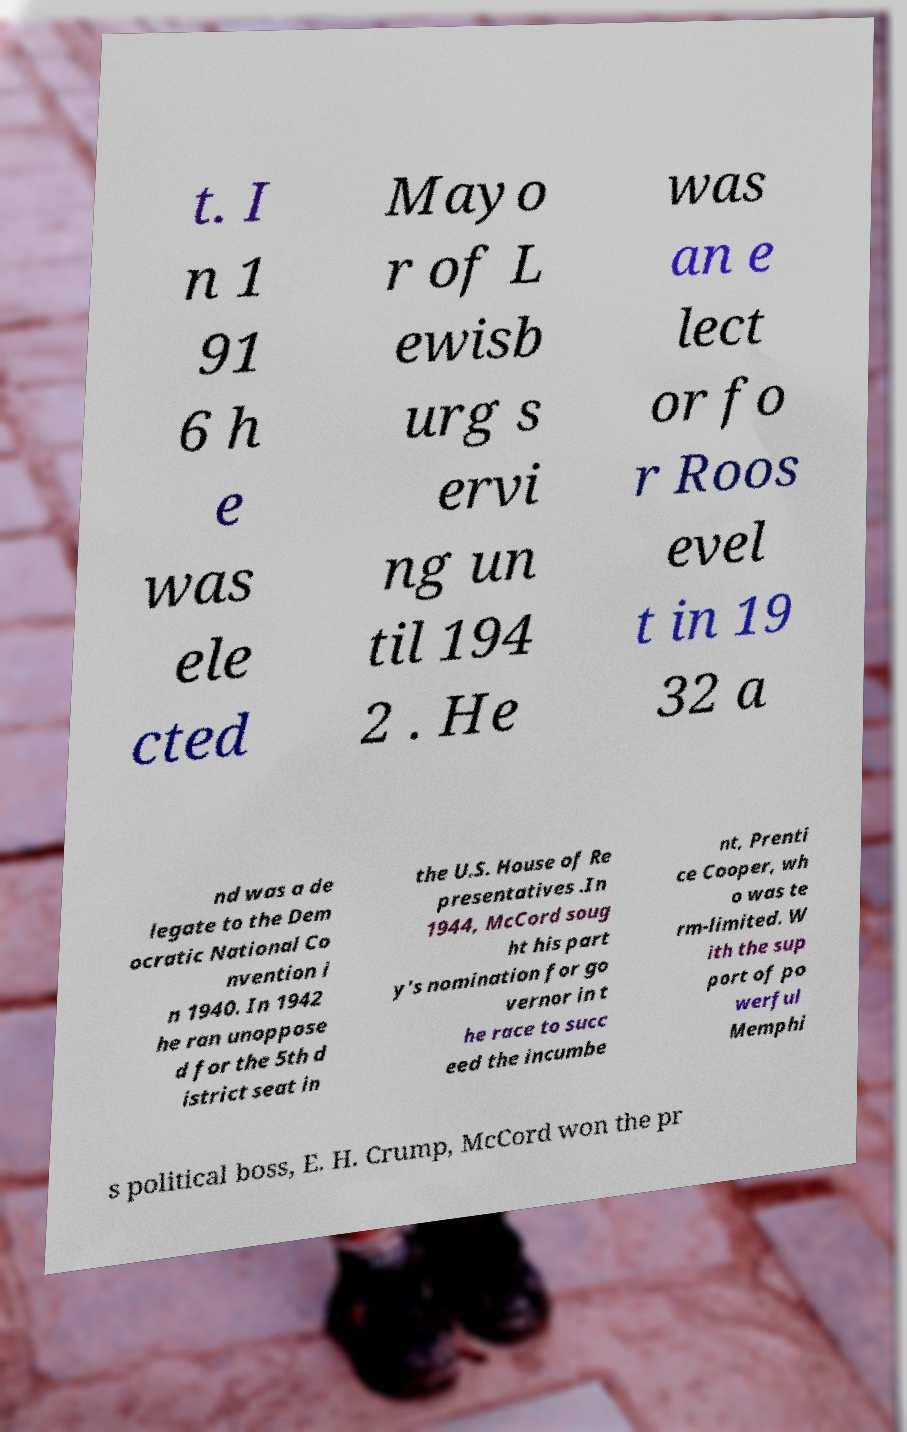Please identify and transcribe the text found in this image. t. I n 1 91 6 h e was ele cted Mayo r of L ewisb urg s ervi ng un til 194 2 . He was an e lect or fo r Roos evel t in 19 32 a nd was a de legate to the Dem ocratic National Co nvention i n 1940. In 1942 he ran unoppose d for the 5th d istrict seat in the U.S. House of Re presentatives .In 1944, McCord soug ht his part y's nomination for go vernor in t he race to succ eed the incumbe nt, Prenti ce Cooper, wh o was te rm-limited. W ith the sup port of po werful Memphi s political boss, E. H. Crump, McCord won the pr 